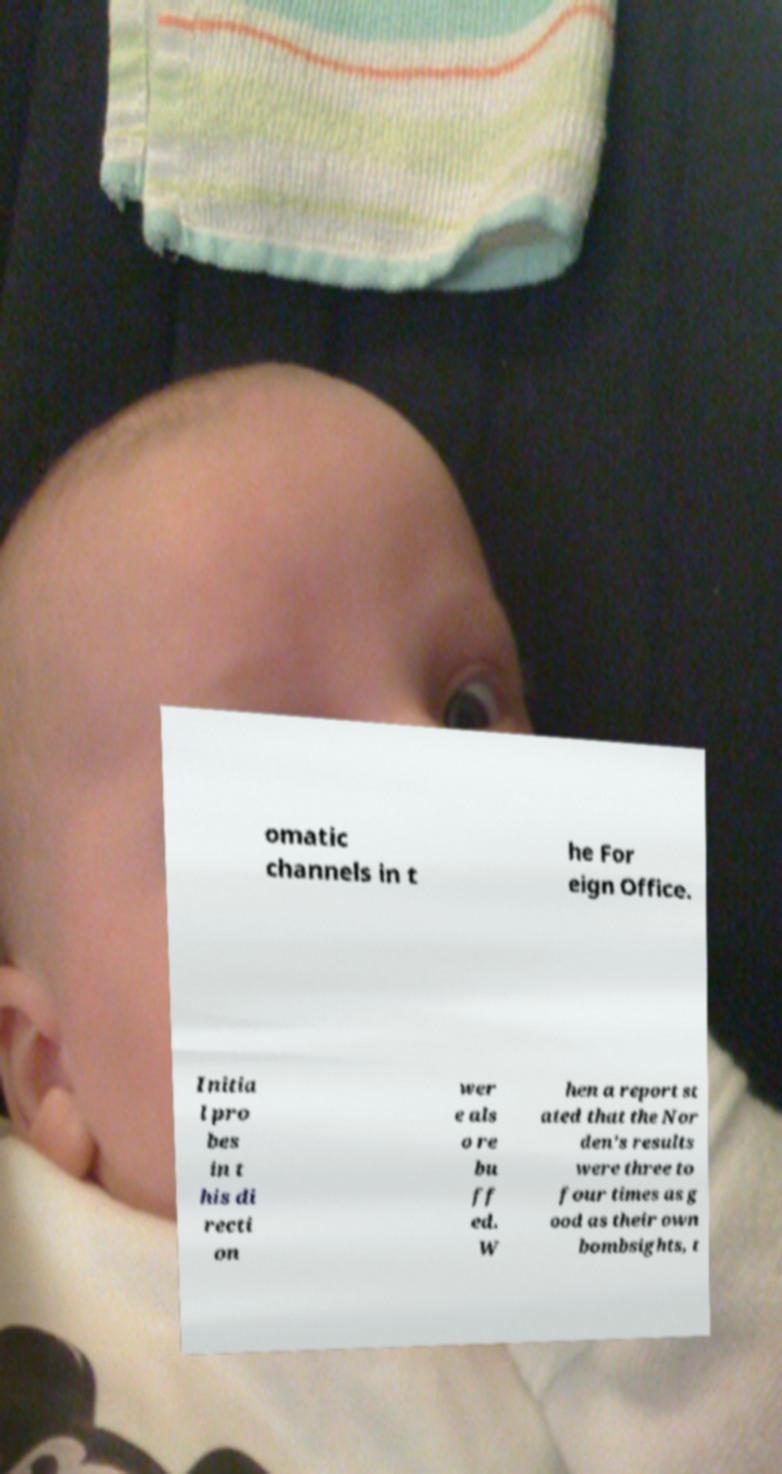Could you extract and type out the text from this image? omatic channels in t he For eign Office. Initia l pro bes in t his di recti on wer e als o re bu ff ed. W hen a report st ated that the Nor den's results were three to four times as g ood as their own bombsights, t 